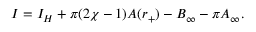<formula> <loc_0><loc_0><loc_500><loc_500>I = I _ { H } + \pi ( 2 \chi - 1 ) A ( r _ { + } ) - B _ { \infty } - \pi A _ { \infty } .</formula> 